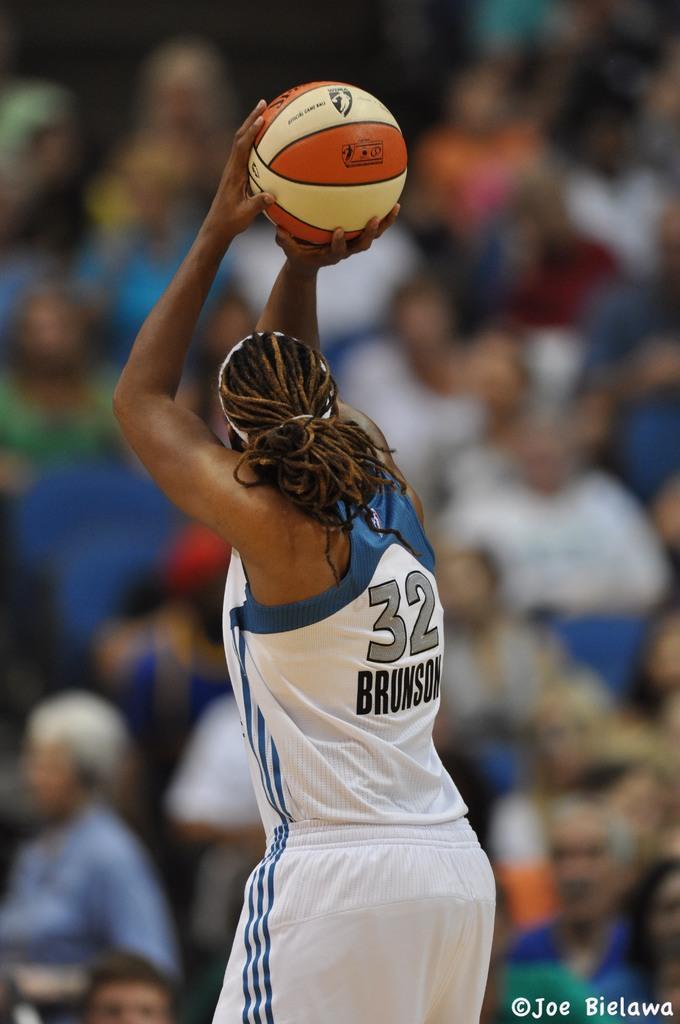In one or two sentences, can you explain what this image depicts? In this image there is a person holding a basketball in his hand, in front of the person there are a few people. 